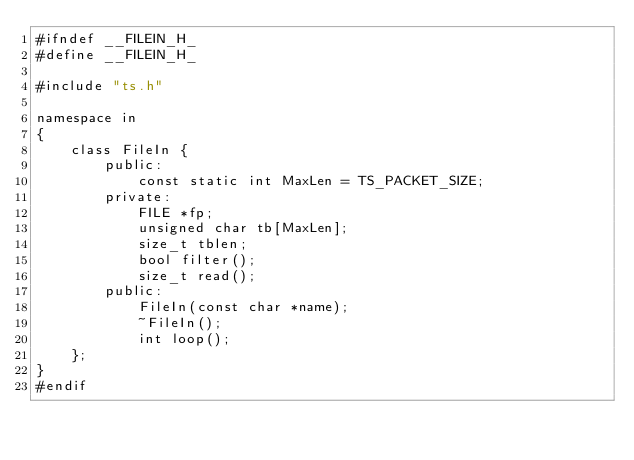<code> <loc_0><loc_0><loc_500><loc_500><_C_>#ifndef __FILEIN_H_
#define __FILEIN_H_

#include "ts.h"

namespace in
{
    class FileIn {
        public:
            const static int MaxLen = TS_PACKET_SIZE;
        private:
            FILE *fp;
            unsigned char tb[MaxLen];
            size_t tblen;
            bool filter();
            size_t read();
        public:
            FileIn(const char *name);
            ~FileIn();
            int loop();
    };
}
#endif
</code> 